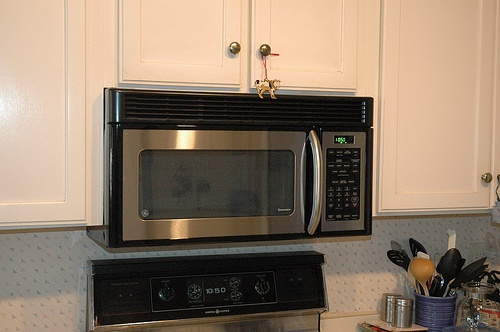Describe the objects in this image and their specific colors. I can see microwave in tan, black, and gray tones, oven in tan, black, and gray tones, spoon in tan, black, maroon, and gray tones, spoon in tan, olive, maroon, gray, and black tones, and spoon in tan, black, and gray tones in this image. 